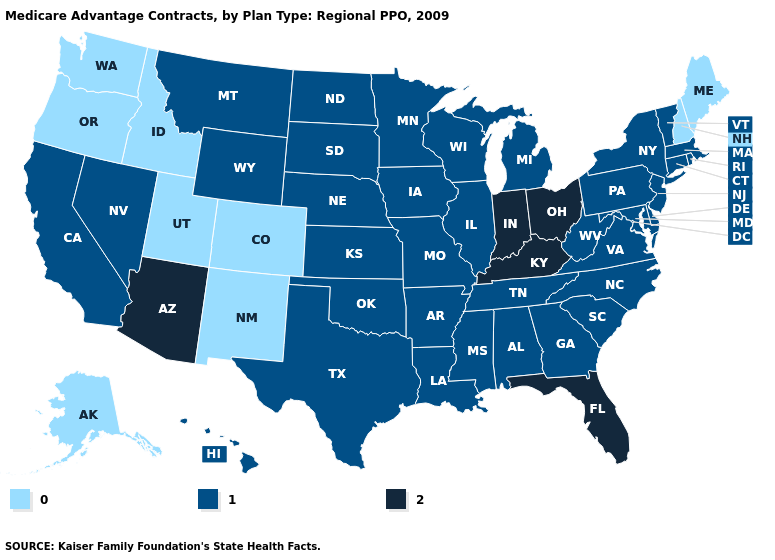What is the value of Texas?
Write a very short answer. 1. Name the states that have a value in the range 2?
Give a very brief answer. Arizona, Florida, Indiana, Kentucky, Ohio. What is the value of Oklahoma?
Be succinct. 1. Among the states that border Texas , which have the highest value?
Give a very brief answer. Arkansas, Louisiana, Oklahoma. What is the lowest value in states that border Arizona?
Quick response, please. 0. Name the states that have a value in the range 0?
Concise answer only. Alaska, Colorado, Idaho, Maine, New Hampshire, New Mexico, Oregon, Utah, Washington. Which states have the lowest value in the South?
Give a very brief answer. Alabama, Arkansas, Delaware, Georgia, Louisiana, Maryland, Mississippi, North Carolina, Oklahoma, South Carolina, Tennessee, Texas, Virginia, West Virginia. Name the states that have a value in the range 0?
Keep it brief. Alaska, Colorado, Idaho, Maine, New Hampshire, New Mexico, Oregon, Utah, Washington. What is the lowest value in the MidWest?
Keep it brief. 1. Name the states that have a value in the range 0?
Concise answer only. Alaska, Colorado, Idaho, Maine, New Hampshire, New Mexico, Oregon, Utah, Washington. Name the states that have a value in the range 1?
Be succinct. Alabama, Arkansas, California, Connecticut, Delaware, Georgia, Hawaii, Iowa, Illinois, Kansas, Louisiana, Massachusetts, Maryland, Michigan, Minnesota, Missouri, Mississippi, Montana, North Carolina, North Dakota, Nebraska, New Jersey, Nevada, New York, Oklahoma, Pennsylvania, Rhode Island, South Carolina, South Dakota, Tennessee, Texas, Virginia, Vermont, Wisconsin, West Virginia, Wyoming. Which states have the highest value in the USA?
Concise answer only. Arizona, Florida, Indiana, Kentucky, Ohio. Which states hav the highest value in the South?
Be succinct. Florida, Kentucky. What is the value of Georgia?
Keep it brief. 1. 